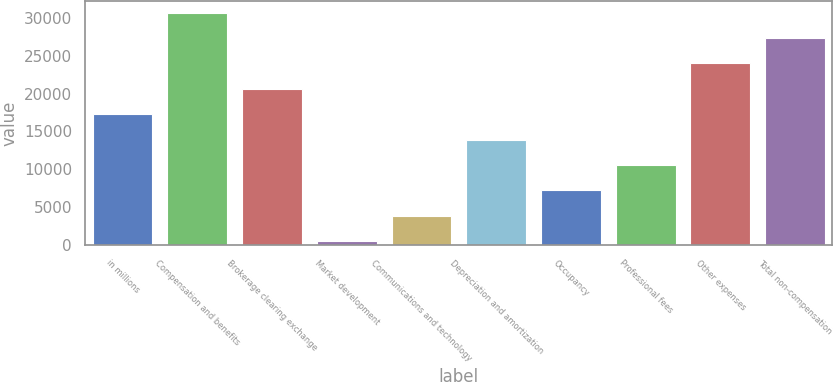<chart> <loc_0><loc_0><loc_500><loc_500><bar_chart><fcel>in millions<fcel>Compensation and benefits<fcel>Brokerage clearing exchange<fcel>Market development<fcel>Communications and technology<fcel>Depreciation and amortization<fcel>Occupancy<fcel>Professional fees<fcel>Other expenses<fcel>Total non-compensation<nl><fcel>17274.5<fcel>30654.9<fcel>20619.6<fcel>549<fcel>3894.1<fcel>13929.4<fcel>7239.2<fcel>10584.3<fcel>23964.7<fcel>27309.8<nl></chart> 